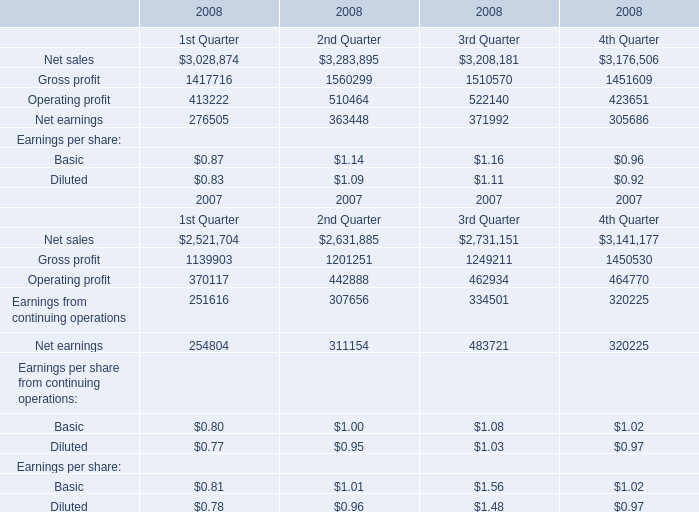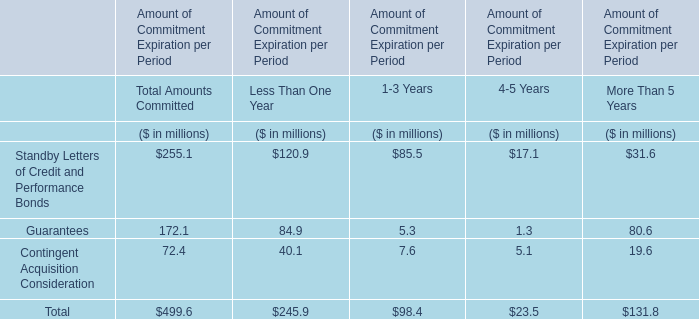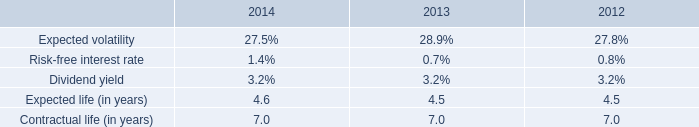what was the percentage change in the weighted-average estimated fair values of stock options granted from 2013 to 2014 
Computations: ((5.74 - 5.27) / 5.27)
Answer: 0.08918. 